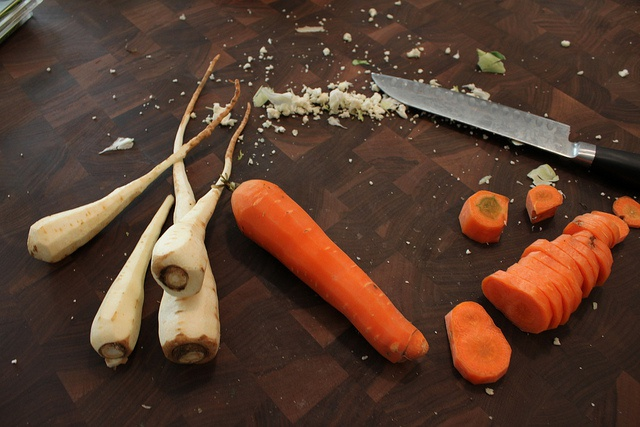Describe the objects in this image and their specific colors. I can see carrot in gray, red, brown, and maroon tones, knife in gray, darkgray, and black tones, carrot in gray, red, brown, and salmon tones, carrot in gray, red, maroon, and brown tones, and carrot in gray, maroon, red, and salmon tones in this image. 